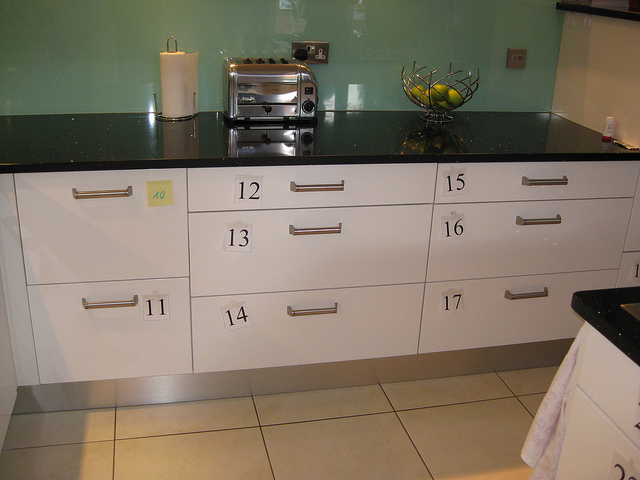Please transcribe the text in this image. 12 13 14 11 16 17 15 